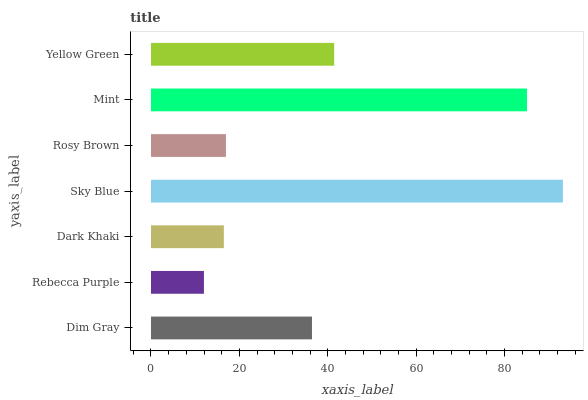Is Rebecca Purple the minimum?
Answer yes or no. Yes. Is Sky Blue the maximum?
Answer yes or no. Yes. Is Dark Khaki the minimum?
Answer yes or no. No. Is Dark Khaki the maximum?
Answer yes or no. No. Is Dark Khaki greater than Rebecca Purple?
Answer yes or no. Yes. Is Rebecca Purple less than Dark Khaki?
Answer yes or no. Yes. Is Rebecca Purple greater than Dark Khaki?
Answer yes or no. No. Is Dark Khaki less than Rebecca Purple?
Answer yes or no. No. Is Dim Gray the high median?
Answer yes or no. Yes. Is Dim Gray the low median?
Answer yes or no. Yes. Is Dark Khaki the high median?
Answer yes or no. No. Is Rebecca Purple the low median?
Answer yes or no. No. 